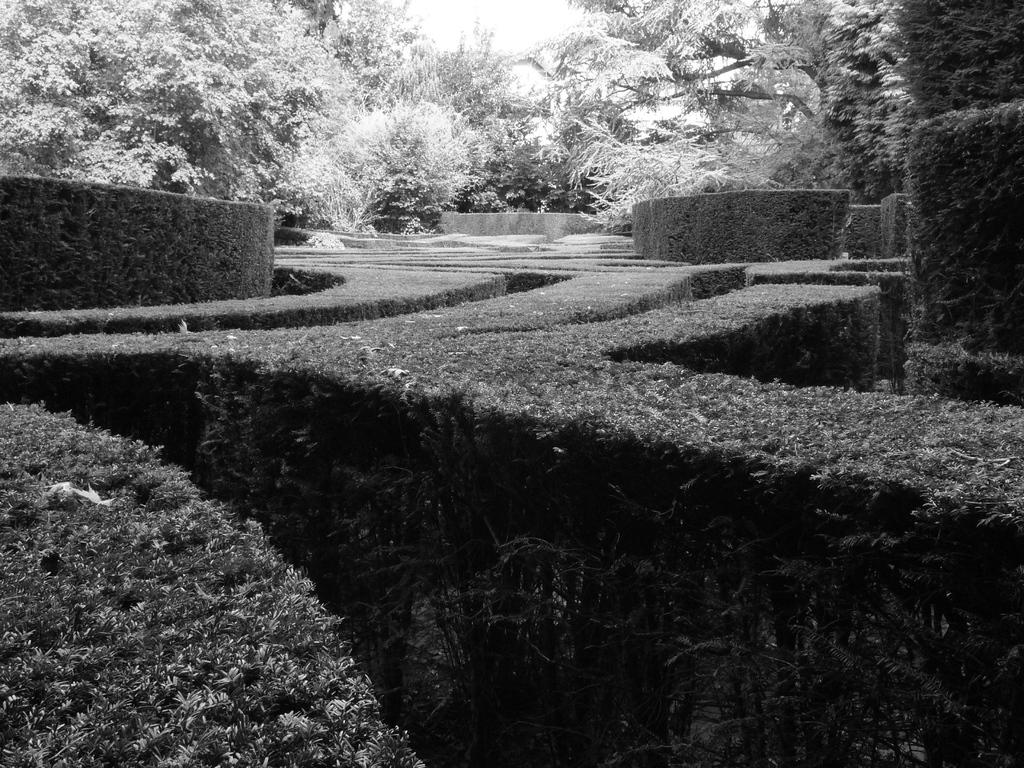What is the color scheme of the image? The image is black and white. What type of vegetation can be seen in the image? There are hedges and trees in the image. What type of cake is being served at the event in the image? There is no event or cake present in the image; it features hedges and trees in a black and white color scheme. 